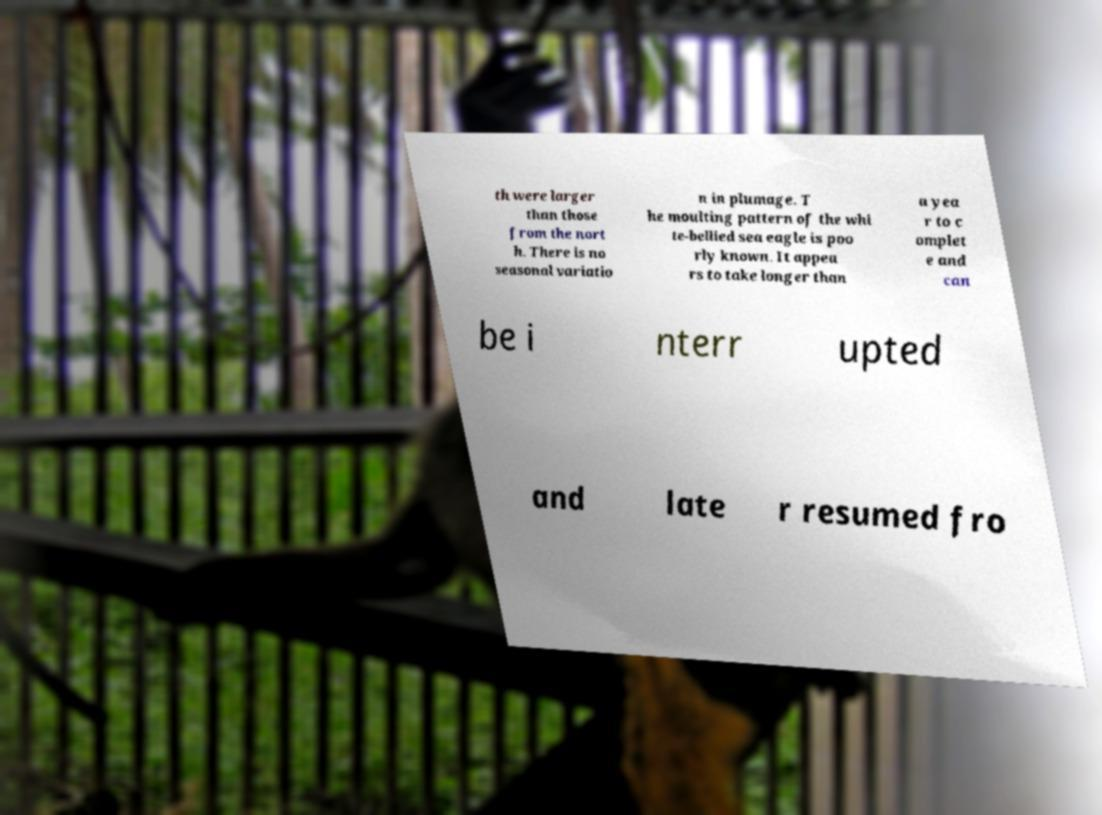Could you assist in decoding the text presented in this image and type it out clearly? th were larger than those from the nort h. There is no seasonal variatio n in plumage. T he moulting pattern of the whi te-bellied sea eagle is poo rly known. It appea rs to take longer than a yea r to c omplet e and can be i nterr upted and late r resumed fro 